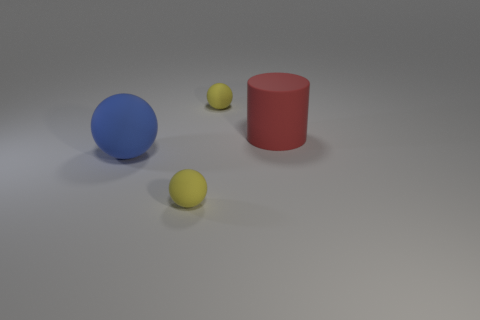Subtract all cyan cylinders. Subtract all purple cubes. How many cylinders are left? 1 Add 1 cubes. How many objects exist? 5 Subtract all balls. How many objects are left? 1 Subtract 0 yellow cubes. How many objects are left? 4 Subtract all rubber things. Subtract all tiny gray spheres. How many objects are left? 0 Add 2 small yellow rubber objects. How many small yellow rubber objects are left? 4 Add 3 tiny brown shiny cubes. How many tiny brown shiny cubes exist? 3 